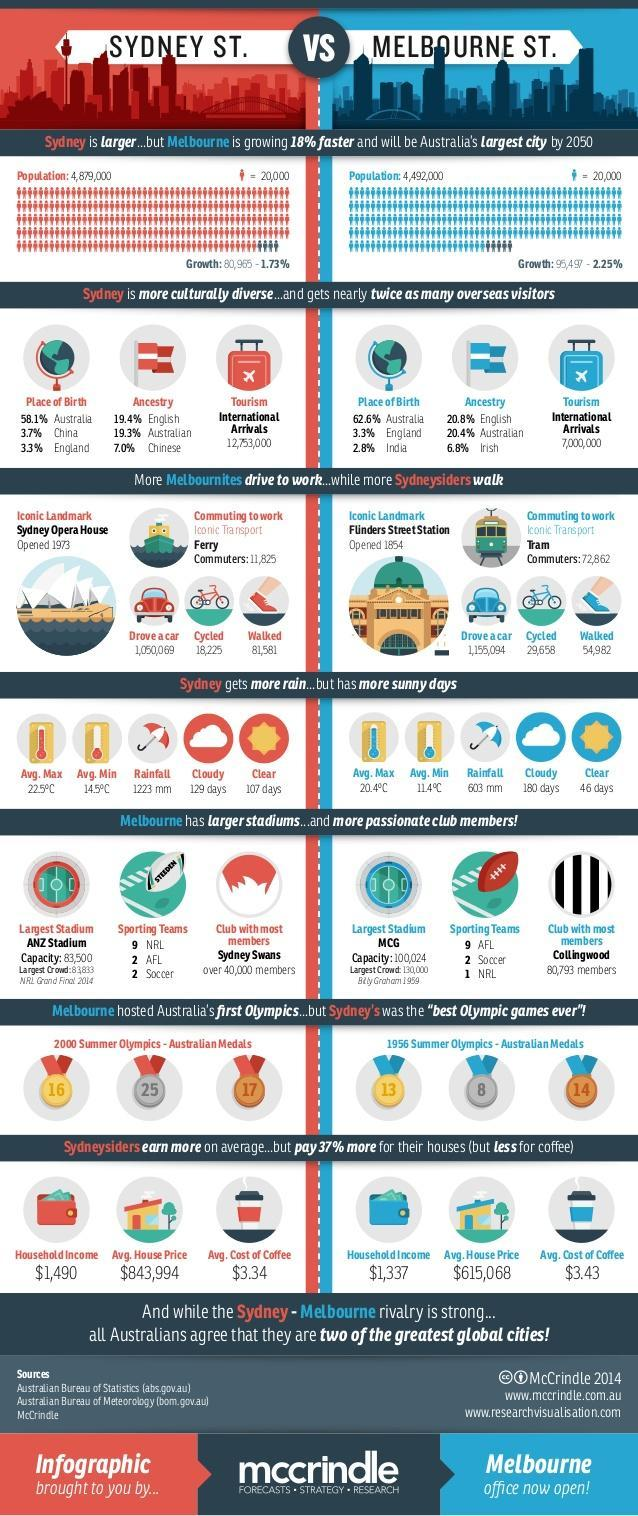How many people in Melbourne commute to work by walking?
Answer the question with a short phrase. 54,982 What is the average household income in Melbourne? $1,337 What is the average house price in Sydney? $843,994 What is the total population of Melbourne? 4,492,000 What is the population growth rate in Sydney? 1.73% How many people in Sydney commute to work by cycling? 18,225 What is the major attraction in Sydney? Sydney Opera House What is the average house price in Melbourne? $615,068 What is the number of  international tourist visitors in Melbourne? 7,000,000 What is the average household income in Sydney? $1,490 